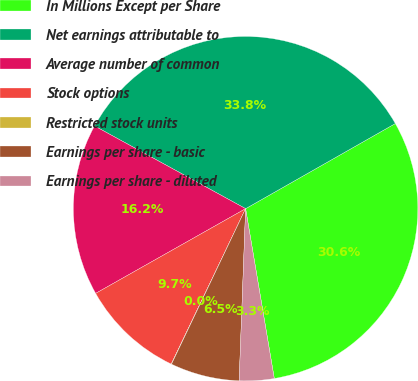<chart> <loc_0><loc_0><loc_500><loc_500><pie_chart><fcel>In Millions Except per Share<fcel>Net earnings attributable to<fcel>Average number of common<fcel>Stock options<fcel>Restricted stock units<fcel>Earnings per share - basic<fcel>Earnings per share - diluted<nl><fcel>30.57%<fcel>33.8%<fcel>16.16%<fcel>9.71%<fcel>0.03%<fcel>6.48%<fcel>3.26%<nl></chart> 